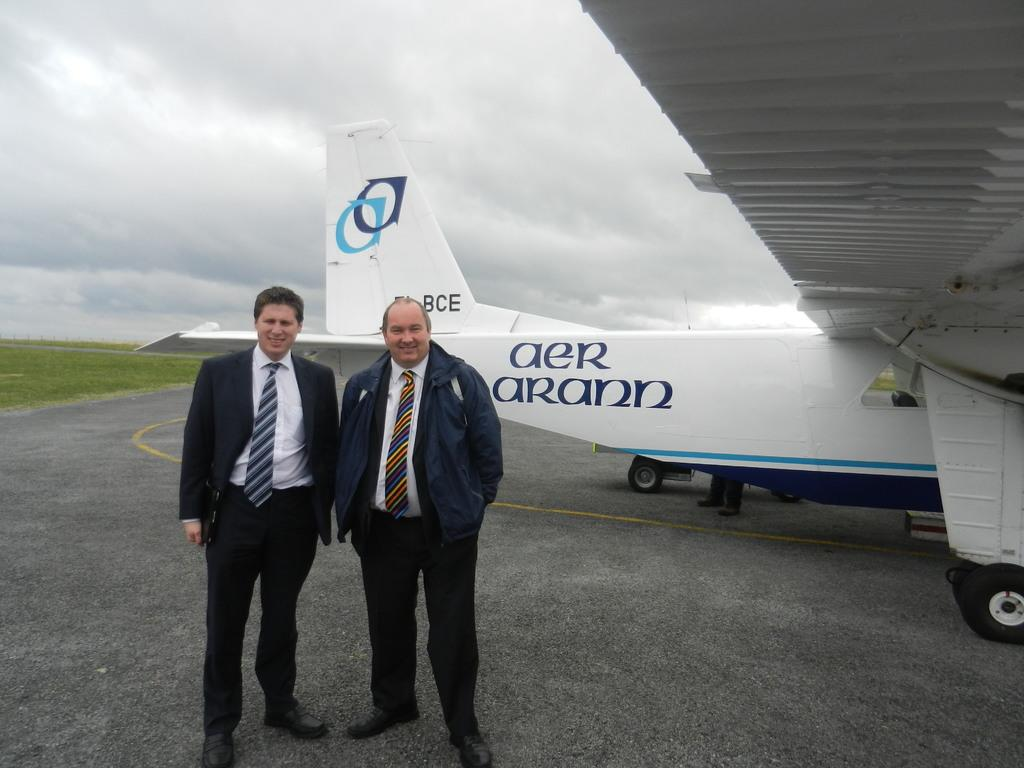<image>
Relay a brief, clear account of the picture shown. two men posing in front of a plane with Aer Arann on it 